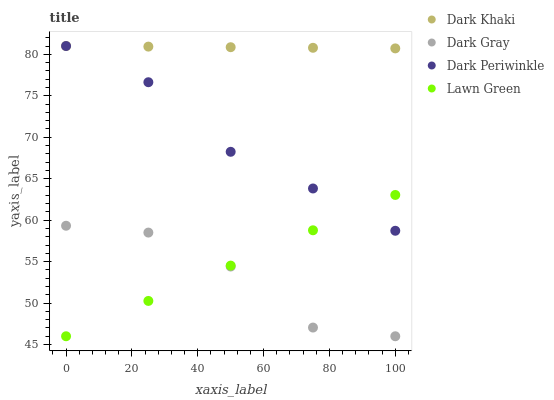Does Dark Gray have the minimum area under the curve?
Answer yes or no. Yes. Does Dark Khaki have the maximum area under the curve?
Answer yes or no. Yes. Does Dark Periwinkle have the minimum area under the curve?
Answer yes or no. No. Does Dark Periwinkle have the maximum area under the curve?
Answer yes or no. No. Is Dark Khaki the smoothest?
Answer yes or no. Yes. Is Dark Gray the roughest?
Answer yes or no. Yes. Is Dark Periwinkle the smoothest?
Answer yes or no. No. Is Dark Periwinkle the roughest?
Answer yes or no. No. Does Dark Gray have the lowest value?
Answer yes or no. Yes. Does Dark Periwinkle have the lowest value?
Answer yes or no. No. Does Dark Periwinkle have the highest value?
Answer yes or no. Yes. Does Dark Gray have the highest value?
Answer yes or no. No. Is Dark Gray less than Dark Periwinkle?
Answer yes or no. Yes. Is Dark Periwinkle greater than Dark Gray?
Answer yes or no. Yes. Does Dark Periwinkle intersect Dark Khaki?
Answer yes or no. Yes. Is Dark Periwinkle less than Dark Khaki?
Answer yes or no. No. Is Dark Periwinkle greater than Dark Khaki?
Answer yes or no. No. Does Dark Gray intersect Dark Periwinkle?
Answer yes or no. No. 